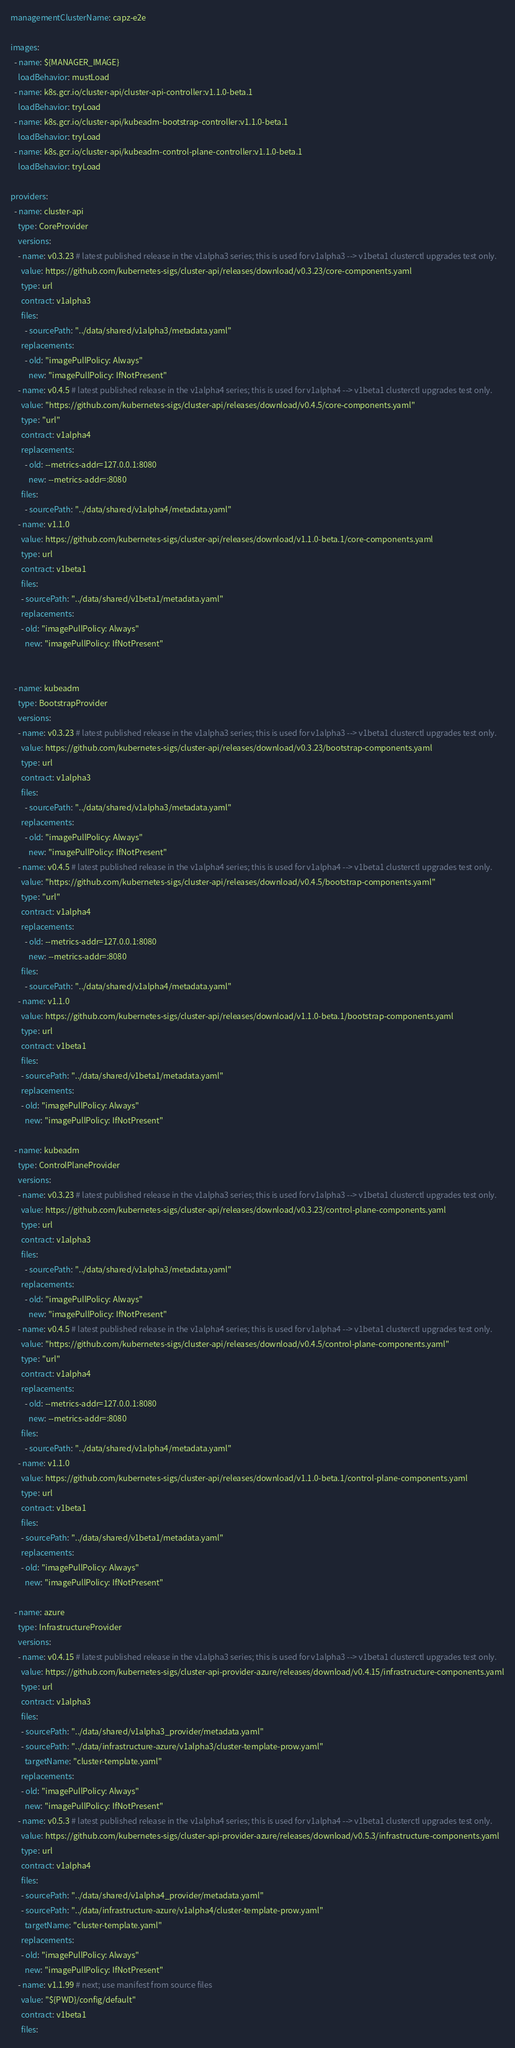Convert code to text. <code><loc_0><loc_0><loc_500><loc_500><_YAML_>managementClusterName: capz-e2e

images:
  - name: ${MANAGER_IMAGE}
    loadBehavior: mustLoad
  - name: k8s.gcr.io/cluster-api/cluster-api-controller:v1.1.0-beta.1
    loadBehavior: tryLoad
  - name: k8s.gcr.io/cluster-api/kubeadm-bootstrap-controller:v1.1.0-beta.1
    loadBehavior: tryLoad
  - name: k8s.gcr.io/cluster-api/kubeadm-control-plane-controller:v1.1.0-beta.1
    loadBehavior: tryLoad

providers:
  - name: cluster-api
    type: CoreProvider
    versions:
    - name: v0.3.23 # latest published release in the v1alpha3 series; this is used for v1alpha3 --> v1beta1 clusterctl upgrades test only.
      value: https://github.com/kubernetes-sigs/cluster-api/releases/download/v0.3.23/core-components.yaml
      type: url
      contract: v1alpha3
      files:
        - sourcePath: "../data/shared/v1alpha3/metadata.yaml"
      replacements:
        - old: "imagePullPolicy: Always"
          new: "imagePullPolicy: IfNotPresent"
    - name: v0.4.5 # latest published release in the v1alpha4 series; this is used for v1alpha4 --> v1beta1 clusterctl upgrades test only.
      value: "https://github.com/kubernetes-sigs/cluster-api/releases/download/v0.4.5/core-components.yaml"
      type: "url"
      contract: v1alpha4
      replacements:
        - old: --metrics-addr=127.0.0.1:8080
          new: --metrics-addr=:8080
      files:
        - sourcePath: "../data/shared/v1alpha4/metadata.yaml"
    - name: v1.1.0
      value: https://github.com/kubernetes-sigs/cluster-api/releases/download/v1.1.0-beta.1/core-components.yaml
      type: url
      contract: v1beta1
      files:
      - sourcePath: "../data/shared/v1beta1/metadata.yaml"
      replacements:
      - old: "imagePullPolicy: Always"
        new: "imagePullPolicy: IfNotPresent"


  - name: kubeadm
    type: BootstrapProvider
    versions:
    - name: v0.3.23 # latest published release in the v1alpha3 series; this is used for v1alpha3 --> v1beta1 clusterctl upgrades test only.
      value: https://github.com/kubernetes-sigs/cluster-api/releases/download/v0.3.23/bootstrap-components.yaml
      type: url
      contract: v1alpha3
      files:
        - sourcePath: "../data/shared/v1alpha3/metadata.yaml"
      replacements:
        - old: "imagePullPolicy: Always"
          new: "imagePullPolicy: IfNotPresent"
    - name: v0.4.5 # latest published release in the v1alpha4 series; this is used for v1alpha4 --> v1beta1 clusterctl upgrades test only.
      value: "https://github.com/kubernetes-sigs/cluster-api/releases/download/v0.4.5/bootstrap-components.yaml"
      type: "url"
      contract: v1alpha4
      replacements:
        - old: --metrics-addr=127.0.0.1:8080
          new: --metrics-addr=:8080
      files:
        - sourcePath: "../data/shared/v1alpha4/metadata.yaml"
    - name: v1.1.0
      value: https://github.com/kubernetes-sigs/cluster-api/releases/download/v1.1.0-beta.1/bootstrap-components.yaml
      type: url
      contract: v1beta1
      files:
      - sourcePath: "../data/shared/v1beta1/metadata.yaml"
      replacements:
      - old: "imagePullPolicy: Always"
        new: "imagePullPolicy: IfNotPresent"

  - name: kubeadm
    type: ControlPlaneProvider
    versions:
    - name: v0.3.23 # latest published release in the v1alpha3 series; this is used for v1alpha3 --> v1beta1 clusterctl upgrades test only.
      value: https://github.com/kubernetes-sigs/cluster-api/releases/download/v0.3.23/control-plane-components.yaml
      type: url
      contract: v1alpha3
      files:
        - sourcePath: "../data/shared/v1alpha3/metadata.yaml"
      replacements:
        - old: "imagePullPolicy: Always"
          new: "imagePullPolicy: IfNotPresent"
    - name: v0.4.5 # latest published release in the v1alpha4 series; this is used for v1alpha4 --> v1beta1 clusterctl upgrades test only.
      value: "https://github.com/kubernetes-sigs/cluster-api/releases/download/v0.4.5/control-plane-components.yaml"
      type: "url"
      contract: v1alpha4
      replacements:
        - old: --metrics-addr=127.0.0.1:8080
          new: --metrics-addr=:8080
      files:
        - sourcePath: "../data/shared/v1alpha4/metadata.yaml"
    - name: v1.1.0
      value: https://github.com/kubernetes-sigs/cluster-api/releases/download/v1.1.0-beta.1/control-plane-components.yaml
      type: url
      contract: v1beta1
      files:
      - sourcePath: "../data/shared/v1beta1/metadata.yaml"
      replacements:
      - old: "imagePullPolicy: Always"
        new: "imagePullPolicy: IfNotPresent"

  - name: azure
    type: InfrastructureProvider
    versions:
    - name: v0.4.15 # latest published release in the v1alpha3 series; this is used for v1alpha3 --> v1beta1 clusterctl upgrades test only.
      value: https://github.com/kubernetes-sigs/cluster-api-provider-azure/releases/download/v0.4.15/infrastructure-components.yaml
      type: url
      contract: v1alpha3
      files:
      - sourcePath: "../data/shared/v1alpha3_provider/metadata.yaml"
      - sourcePath: "../data/infrastructure-azure/v1alpha3/cluster-template-prow.yaml"
        targetName: "cluster-template.yaml"
      replacements:
      - old: "imagePullPolicy: Always"
        new: "imagePullPolicy: IfNotPresent"
    - name: v0.5.3 # latest published release in the v1alpha4 series; this is used for v1alpha4 --> v1beta1 clusterctl upgrades test only.
      value: https://github.com/kubernetes-sigs/cluster-api-provider-azure/releases/download/v0.5.3/infrastructure-components.yaml
      type: url
      contract: v1alpha4
      files:
      - sourcePath: "../data/shared/v1alpha4_provider/metadata.yaml"
      - sourcePath: "../data/infrastructure-azure/v1alpha4/cluster-template-prow.yaml"
        targetName: "cluster-template.yaml"
      replacements:
      - old: "imagePullPolicy: Always"
        new: "imagePullPolicy: IfNotPresent"
    - name: v1.1.99 # next; use manifest from source files
      value: "${PWD}/config/default"
      contract: v1beta1
      files:</code> 